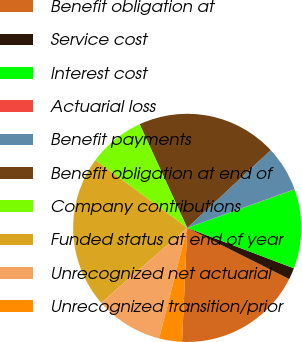Convert chart. <chart><loc_0><loc_0><loc_500><loc_500><pie_chart><fcel>Benefit obligation at<fcel>Service cost<fcel>Interest cost<fcel>Actuarial loss<fcel>Benefit payments<fcel>Benefit obligation at end of<fcel>Company contributions<fcel>Funded status at end of year<fcel>Unrecognized net actuarial<fcel>Unrecognized transition/prior<nl><fcel>18.32%<fcel>1.64%<fcel>11.23%<fcel>0.04%<fcel>6.43%<fcel>19.92%<fcel>8.03%<fcel>21.52%<fcel>9.63%<fcel>3.24%<nl></chart> 